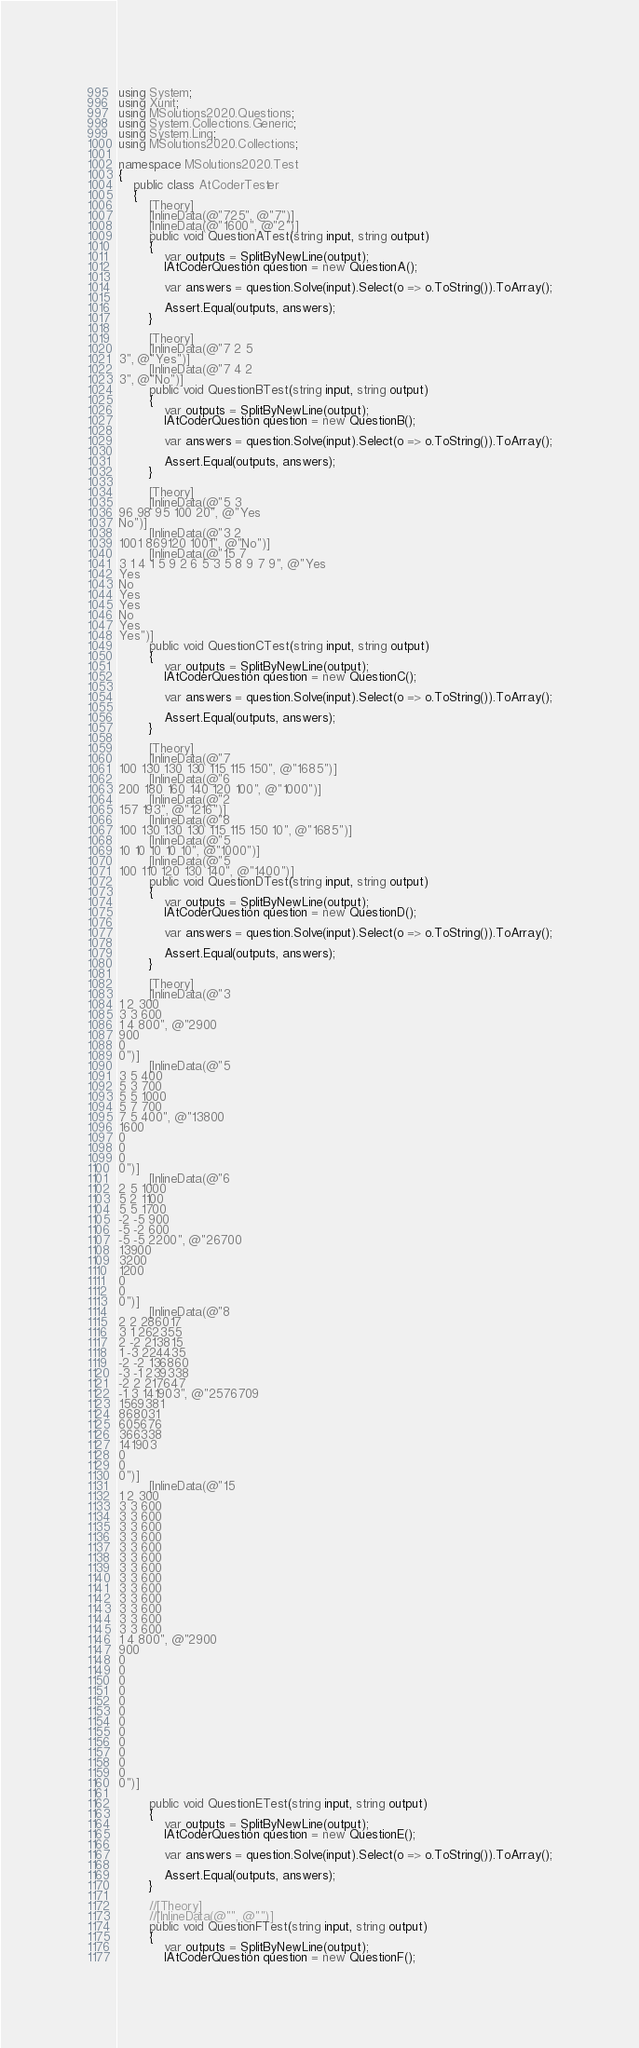Convert code to text. <code><loc_0><loc_0><loc_500><loc_500><_C#_>using System;
using Xunit;
using MSolutions2020.Questions;
using System.Collections.Generic;
using System.Linq;
using MSolutions2020.Collections;

namespace MSolutions2020.Test
{
    public class AtCoderTester
    {
        [Theory]
        [InlineData(@"725", @"7")]
        [InlineData(@"1600", @"2")]
        public void QuestionATest(string input, string output)
        {
            var outputs = SplitByNewLine(output);
            IAtCoderQuestion question = new QuestionA();

            var answers = question.Solve(input).Select(o => o.ToString()).ToArray();

            Assert.Equal(outputs, answers);
        }

        [Theory]
        [InlineData(@"7 2 5
3", @"Yes")]
        [InlineData(@"7 4 2
3", @"No")]
        public void QuestionBTest(string input, string output)
        {
            var outputs = SplitByNewLine(output);
            IAtCoderQuestion question = new QuestionB();

            var answers = question.Solve(input).Select(o => o.ToString()).ToArray();

            Assert.Equal(outputs, answers);
        }

        [Theory]
        [InlineData(@"5 3
96 98 95 100 20", @"Yes
No")]
        [InlineData(@"3 2
1001 869120 1001", @"No")]
        [InlineData(@"15 7
3 1 4 1 5 9 2 6 5 3 5 8 9 7 9", @"Yes
Yes
No
Yes
Yes
No
Yes
Yes")]
        public void QuestionCTest(string input, string output)
        {
            var outputs = SplitByNewLine(output);
            IAtCoderQuestion question = new QuestionC();

            var answers = question.Solve(input).Select(o => o.ToString()).ToArray();

            Assert.Equal(outputs, answers);
        }

        [Theory]
        [InlineData(@"7
100 130 130 130 115 115 150", @"1685")]
        [InlineData(@"6
200 180 160 140 120 100", @"1000")]
        [InlineData(@"2
157 193", @"1216")]
        [InlineData(@"8
100 130 130 130 115 115 150 10", @"1685")]
        [InlineData(@"5
10 10 10 10 10", @"1000")]
        [InlineData(@"5
100 110 120 130 140", @"1400")]
        public void QuestionDTest(string input, string output)
        {
            var outputs = SplitByNewLine(output);
            IAtCoderQuestion question = new QuestionD();

            var answers = question.Solve(input).Select(o => o.ToString()).ToArray();

            Assert.Equal(outputs, answers);
        }

        [Theory]
        [InlineData(@"3
1 2 300
3 3 600
1 4 800", @"2900
900
0
0")]
        [InlineData(@"5
3 5 400
5 3 700
5 5 1000
5 7 700
7 5 400", @"13800
1600
0
0
0
0")]
        [InlineData(@"6
2 5 1000
5 2 1100
5 5 1700
-2 -5 900
-5 -2 600
-5 -5 2200", @"26700
13900
3200
1200
0
0
0")]
        [InlineData(@"8
2 2 286017
3 1 262355
2 -2 213815
1 -3 224435
-2 -2 136860
-3 -1 239338
-2 2 217647
-1 3 141903", @"2576709
1569381
868031
605676
366338
141903
0
0
0")]
        [InlineData(@"15
1 2 300
3 3 600
3 3 600
3 3 600
3 3 600
3 3 600
3 3 600
3 3 600
3 3 600
3 3 600
3 3 600
3 3 600
3 3 600
3 3 600
1 4 800", @"2900
900
0
0
0
0
0
0
0
0
0
0
0
0
0")]

        public void QuestionETest(string input, string output)
        {
            var outputs = SplitByNewLine(output);
            IAtCoderQuestion question = new QuestionE();

            var answers = question.Solve(input).Select(o => o.ToString()).ToArray();

            Assert.Equal(outputs, answers);
        }

        //[Theory]
        //[InlineData(@"", @"")]
        public void QuestionFTest(string input, string output)
        {
            var outputs = SplitByNewLine(output);
            IAtCoderQuestion question = new QuestionF();
</code> 